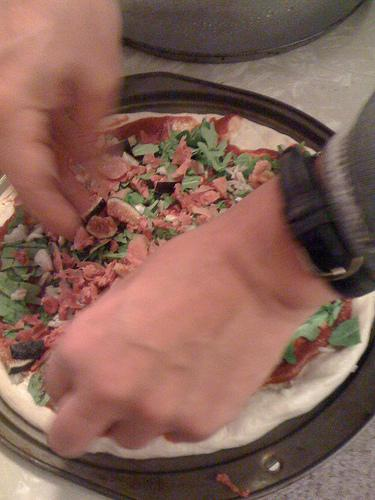Question: what is happening in this photo?
Choices:
A. A person is making stew.
B. A person is making pizza.
C. A person is making pasta.
D. A person is making tacos.
Answer with the letter. Answer: B Question: how many hands are visible?
Choices:
A. Two.
B. One.
C. None.
D. Three.
Answer with the letter. Answer: A Question: what color is the table?
Choices:
A. Gray.
B. Brown.
C. Red.
D. Gold.
Answer with the letter. Answer: A Question: why are this person's hands blurry?
Choices:
A. They are in motion.
B. They are distingrating.
C. The photo quality is bad.
D. It is hazy.
Answer with the letter. Answer: A Question: what is on this persons wrist?
Choices:
A. A bracelet.
B. An armband.
C. A watch.
D. A pedometer.
Answer with the letter. Answer: C Question: when was this photo taken?
Choices:
A. During construction.
B. During food preparation.
C. During event planning.
D. During traffic direction.
Answer with the letter. Answer: B 